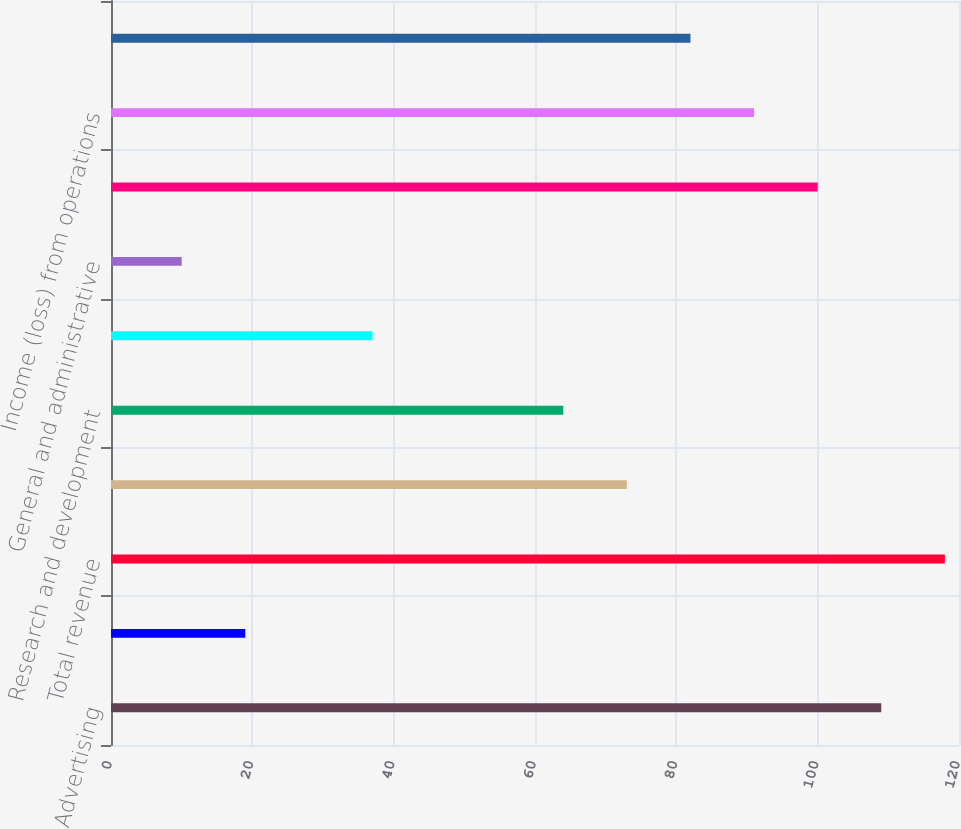Convert chart to OTSL. <chart><loc_0><loc_0><loc_500><loc_500><bar_chart><fcel>Advertising<fcel>Payments and other fees<fcel>Total revenue<fcel>Cost of revenue<fcel>Research and development<fcel>Marketing and sales<fcel>General and administrative<fcel>Total costs and expenses<fcel>Income (loss) from operations<fcel>Income (loss) before provision<nl><fcel>109<fcel>19<fcel>118<fcel>73<fcel>64<fcel>37<fcel>10<fcel>100<fcel>91<fcel>82<nl></chart> 